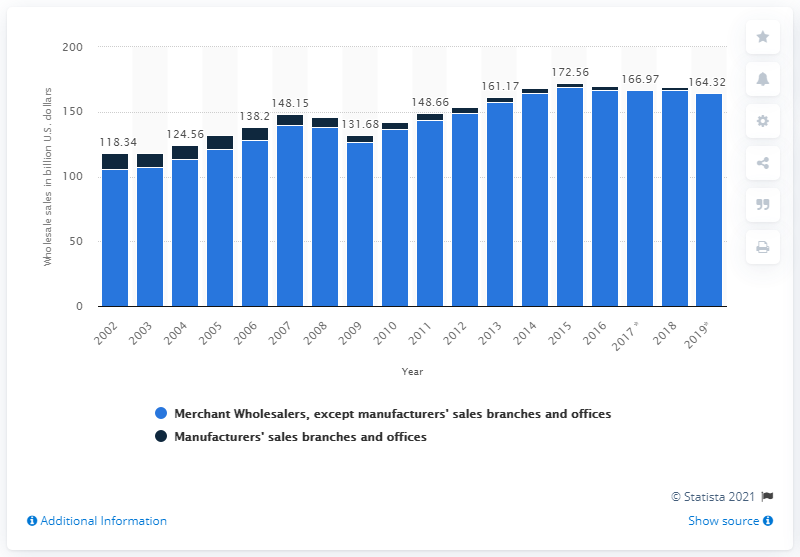List a handful of essential elements in this visual. In 2019, the sales of apparel, piece goods, and notions by merchant wholesalers totaled 164.32 